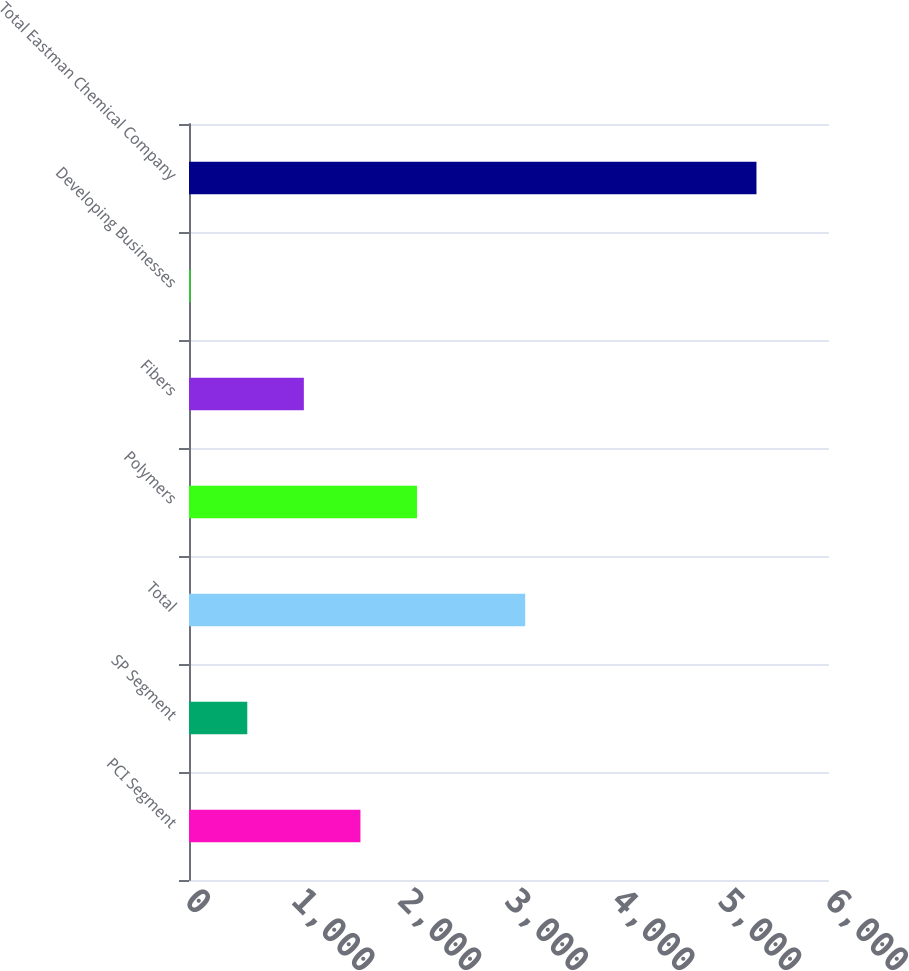Convert chart to OTSL. <chart><loc_0><loc_0><loc_500><loc_500><bar_chart><fcel>PCI Segment<fcel>SP Segment<fcel>Total<fcel>Polymers<fcel>Fibers<fcel>Developing Businesses<fcel>Total Eastman Chemical Company<nl><fcel>1607.2<fcel>546.4<fcel>3152<fcel>2137.6<fcel>1076.8<fcel>16<fcel>5320<nl></chart> 